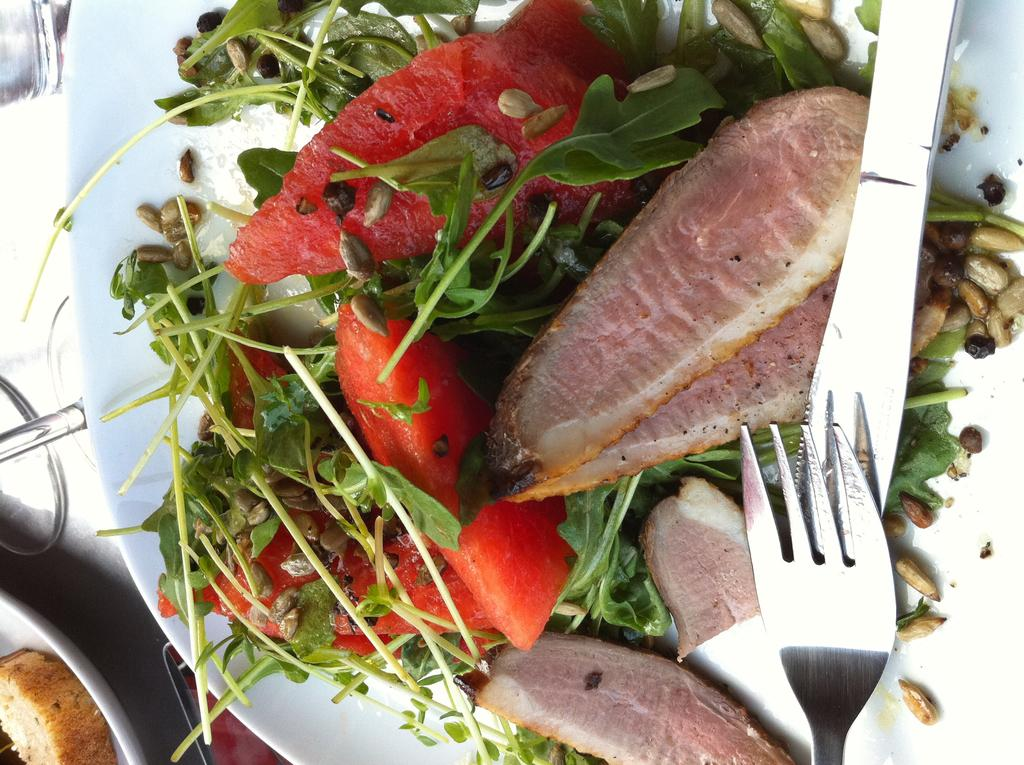What type of objects can be seen in the image related to food? There are food items in the image. What utensils are present in the image? There is a fork and a knife in the image. Where are the fork and knife located? The fork and knife are on plates in the image. What else can be seen on the table in the image? There are glasses on the table. What type of dress is being worn by the power source in the image? There is no power source or dress present in the image. 